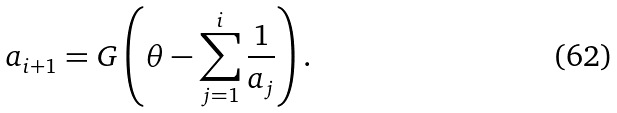<formula> <loc_0><loc_0><loc_500><loc_500>a _ { i + 1 } = G \left ( \theta - \sum _ { j = 1 } ^ { i } \frac { 1 } { a _ { j } } \right ) .</formula> 